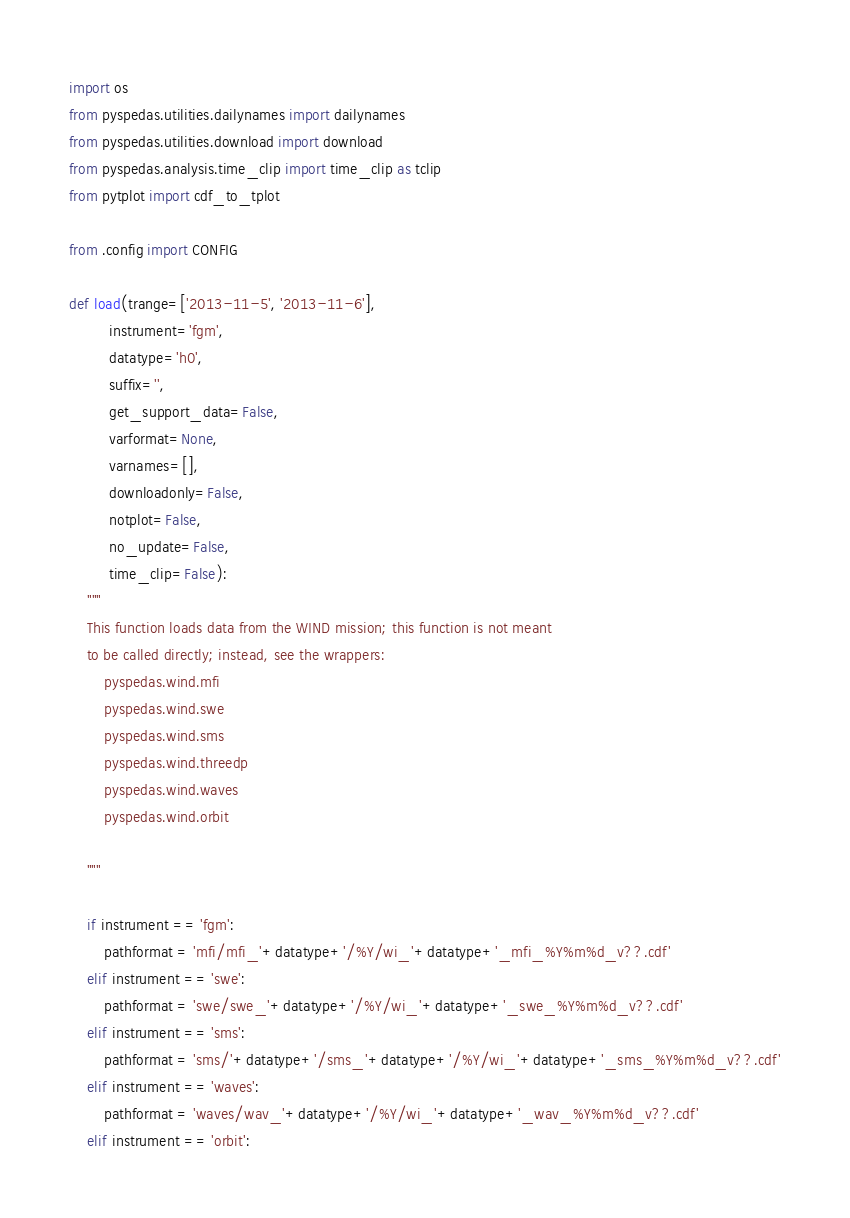Convert code to text. <code><loc_0><loc_0><loc_500><loc_500><_Python_>import os
from pyspedas.utilities.dailynames import dailynames
from pyspedas.utilities.download import download
from pyspedas.analysis.time_clip import time_clip as tclip
from pytplot import cdf_to_tplot

from .config import CONFIG

def load(trange=['2013-11-5', '2013-11-6'], 
         instrument='fgm',
         datatype='h0', 
         suffix='', 
         get_support_data=False, 
         varformat=None,
         varnames=[],
         downloadonly=False,
         notplot=False,
         no_update=False,
         time_clip=False):
    """
    This function loads data from the WIND mission; this function is not meant 
    to be called directly; instead, see the wrappers:
        pyspedas.wind.mfi
        pyspedas.wind.swe
        pyspedas.wind.sms
        pyspedas.wind.threedp
        pyspedas.wind.waves
        pyspedas.wind.orbit

    """

    if instrument == 'fgm':
        pathformat = 'mfi/mfi_'+datatype+'/%Y/wi_'+datatype+'_mfi_%Y%m%d_v??.cdf'
    elif instrument == 'swe':
        pathformat = 'swe/swe_'+datatype+'/%Y/wi_'+datatype+'_swe_%Y%m%d_v??.cdf'
    elif instrument == 'sms':
        pathformat = 'sms/'+datatype+'/sms_'+datatype+'/%Y/wi_'+datatype+'_sms_%Y%m%d_v??.cdf'
    elif instrument == 'waves':
        pathformat = 'waves/wav_'+datatype+'/%Y/wi_'+datatype+'_wav_%Y%m%d_v??.cdf'
    elif instrument == 'orbit':</code> 